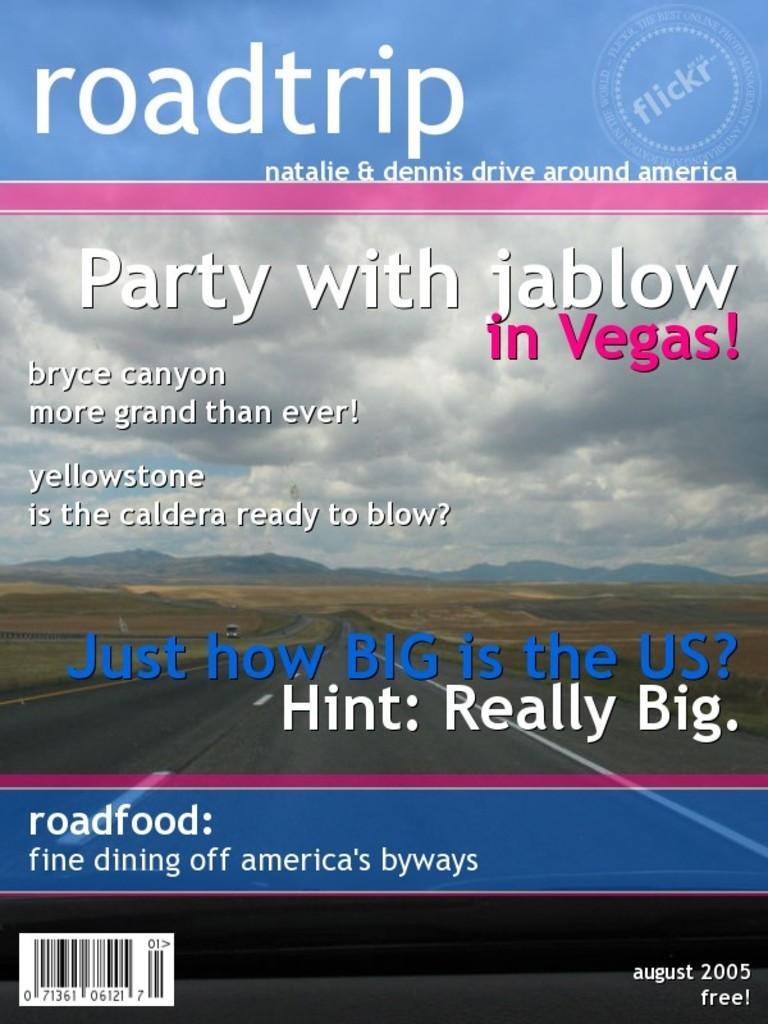<image>
Relay a brief, clear account of the picture shown. a magazine that has 'roadtrip' at the top of it in white letters. 